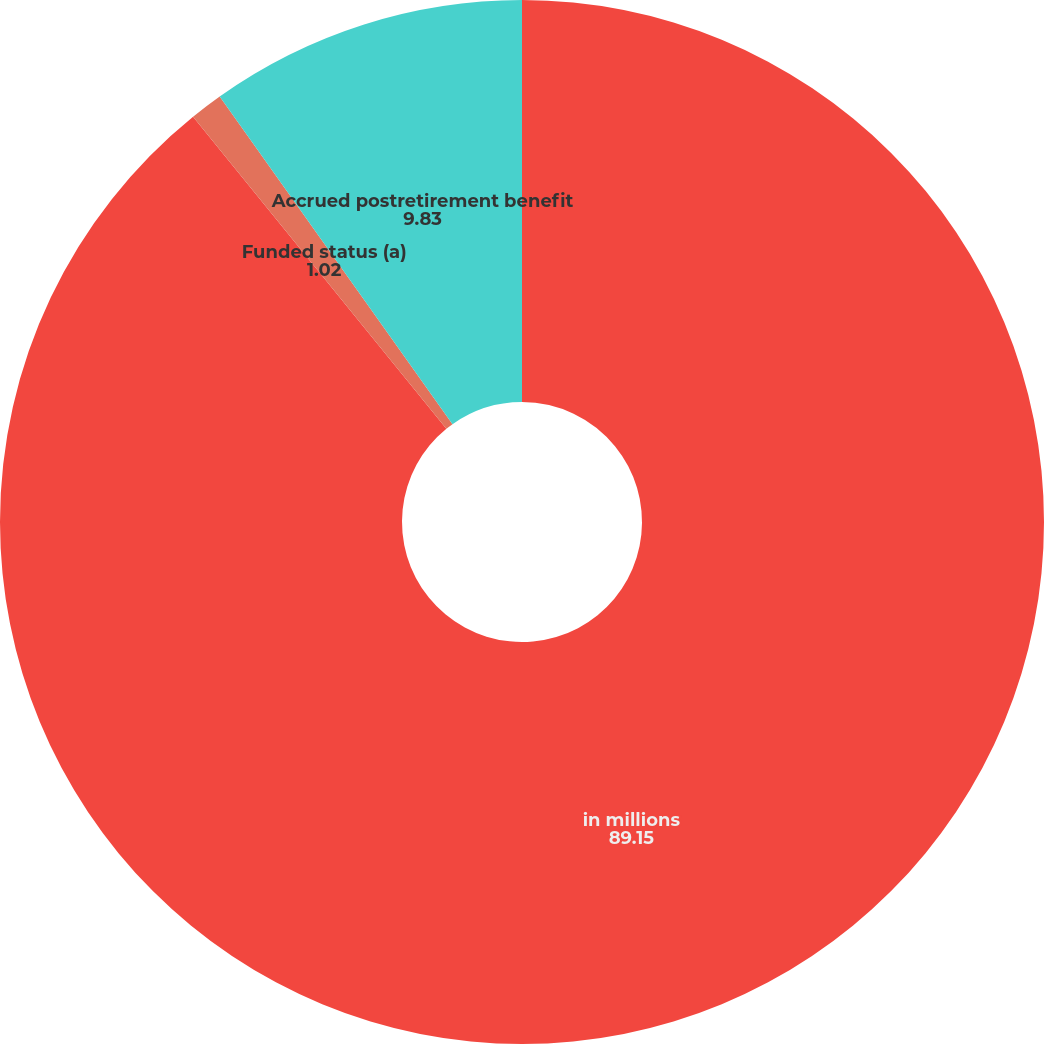Convert chart. <chart><loc_0><loc_0><loc_500><loc_500><pie_chart><fcel>in millions<fcel>Funded status (a)<fcel>Accrued postretirement benefit<nl><fcel>89.15%<fcel>1.02%<fcel>9.83%<nl></chart> 